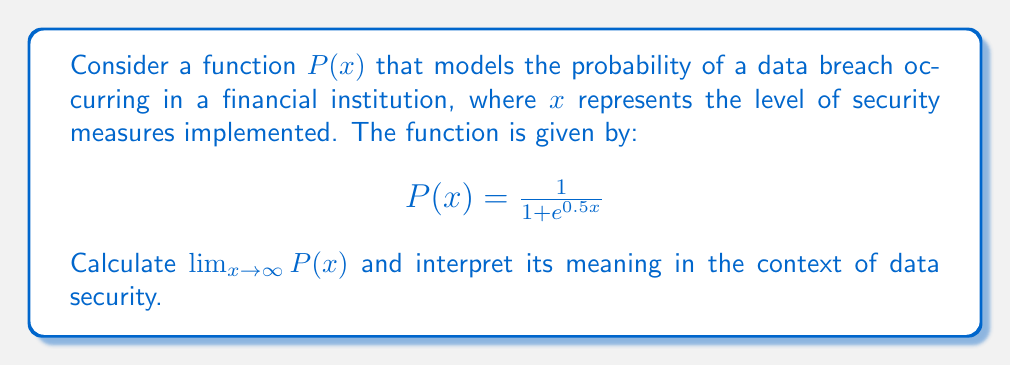Could you help me with this problem? To solve this problem, we'll follow these steps:

1) First, let's examine the behavior of the function as $x$ approaches infinity:

   As $x \to \infty$, $e^{0.5x} \to \infty$ because $e^x$ grows exponentially.

2) Now, let's look at the limit:

   $$\lim_{x \to \infty} P(x) = \lim_{x \to \infty} \frac{1}{1 + e^{0.5x}}$$

3) As the denominator grows infinitely large, the fraction will approach zero:

   $$\lim_{x \to \infty} \frac{1}{1 + e^{0.5x}} = \frac{1}{\infty} = 0$$

4) We can verify this using L'Hôpital's rule:

   $$\lim_{x \to \infty} \frac{1}{1 + e^{0.5x}} = \lim_{x \to \infty} \frac{0}{0.5e^{0.5x}} = 0$$

5) Interpretation:
   The limit being 0 means that as the level of security measures ($x$) increases indefinitely, the probability of a data breach ($P(x)$) approaches 0. This suggests that with continual improvement in security measures, the risk of a data breach can be minimized, though never completely eliminated in practice.
Answer: $\lim_{x \to \infty} P(x) = 0$

This means that as security measures increase indefinitely, the probability of a data breach approaches zero. 